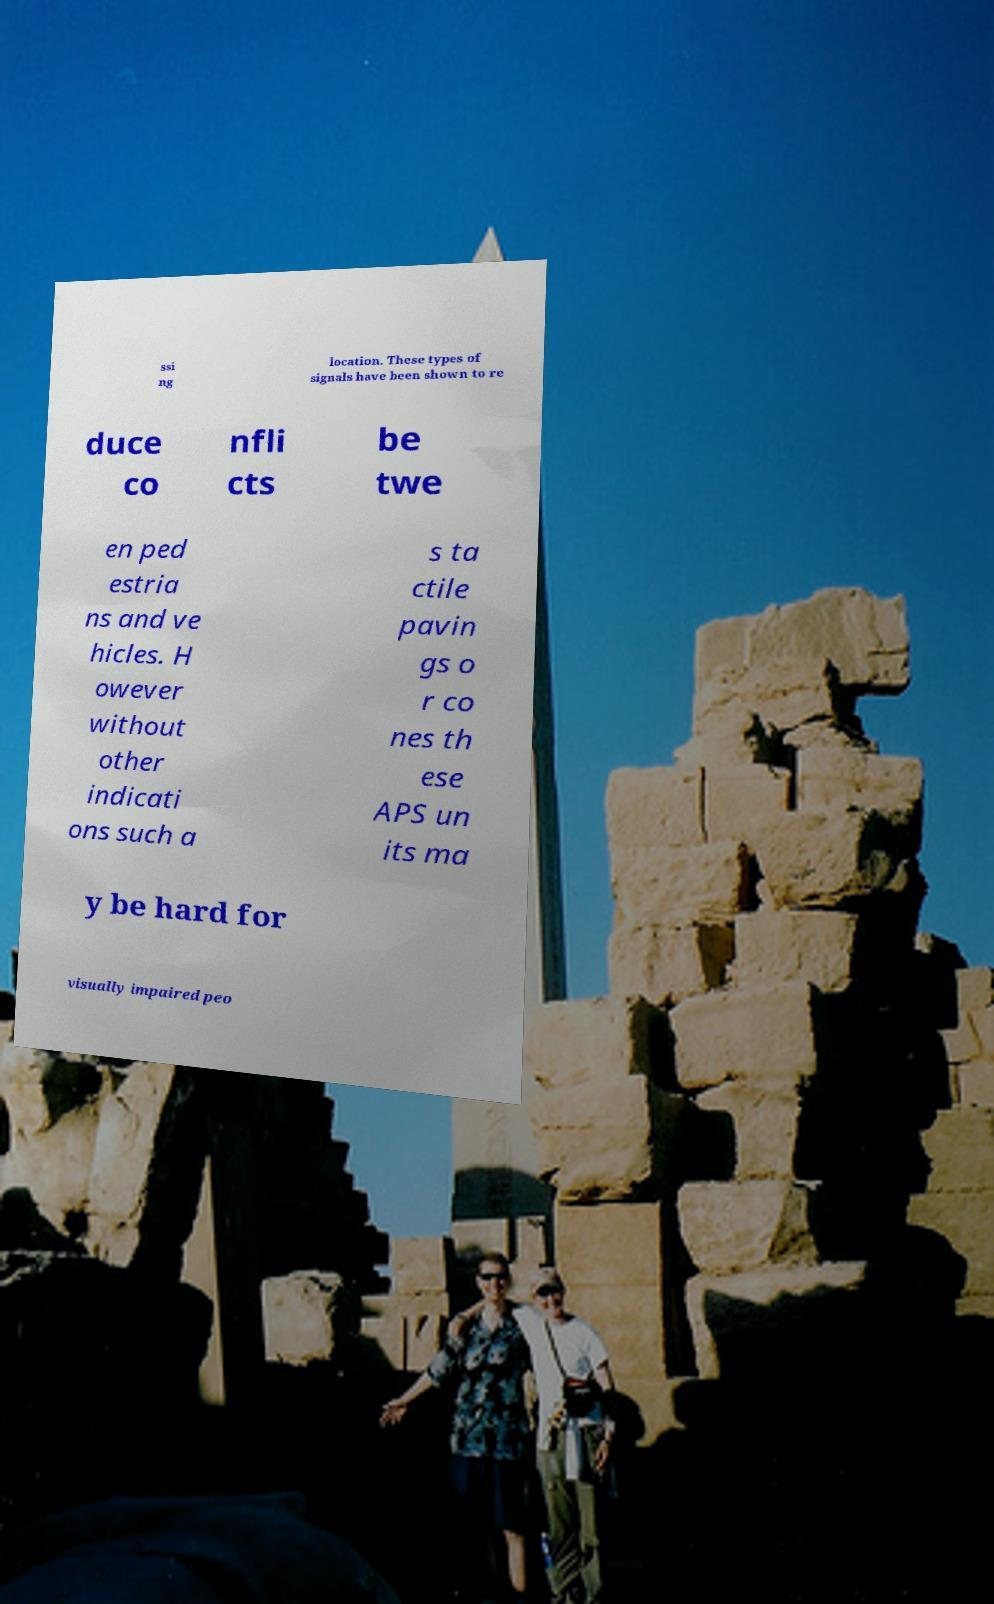Could you assist in decoding the text presented in this image and type it out clearly? ssi ng location. These types of signals have been shown to re duce co nfli cts be twe en ped estria ns and ve hicles. H owever without other indicati ons such a s ta ctile pavin gs o r co nes th ese APS un its ma y be hard for visually impaired peo 